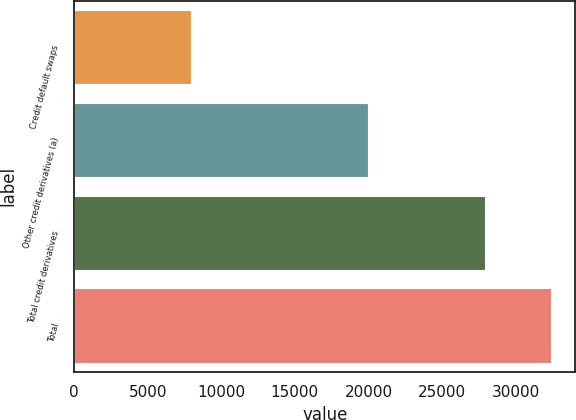<chart> <loc_0><loc_0><loc_500><loc_500><bar_chart><fcel>Credit default swaps<fcel>Other credit derivatives (a)<fcel>Total credit derivatives<fcel>Total<nl><fcel>7935<fcel>19991<fcel>27926<fcel>32431<nl></chart> 